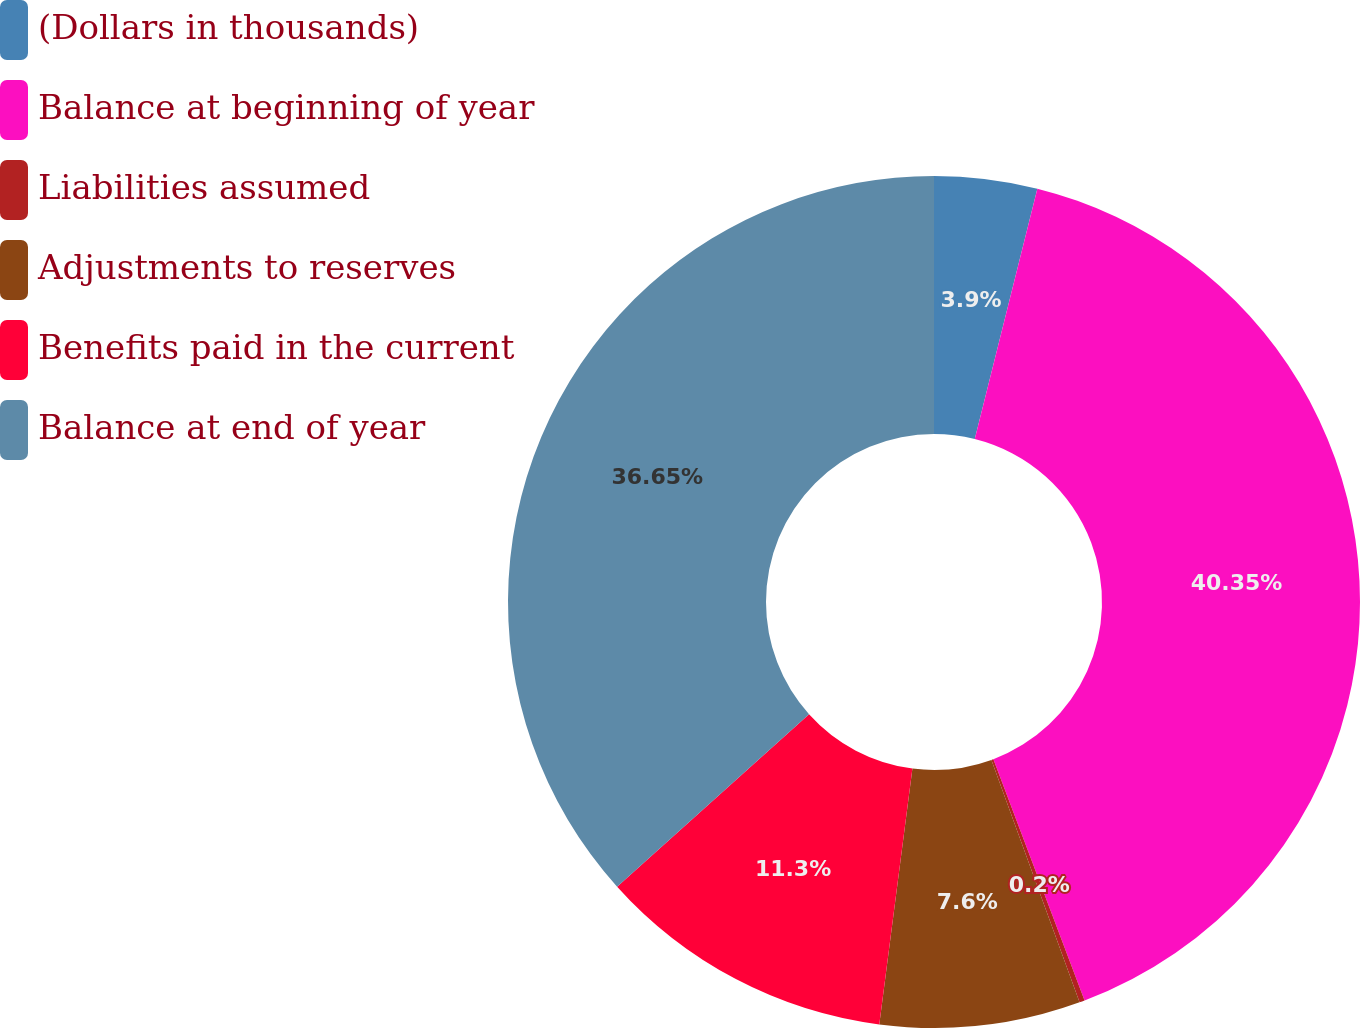Convert chart to OTSL. <chart><loc_0><loc_0><loc_500><loc_500><pie_chart><fcel>(Dollars in thousands)<fcel>Balance at beginning of year<fcel>Liabilities assumed<fcel>Adjustments to reserves<fcel>Benefits paid in the current<fcel>Balance at end of year<nl><fcel>3.9%<fcel>40.35%<fcel>0.2%<fcel>7.6%<fcel>11.3%<fcel>36.65%<nl></chart> 